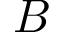Convert formula to latex. <formula><loc_0><loc_0><loc_500><loc_500>B</formula> 